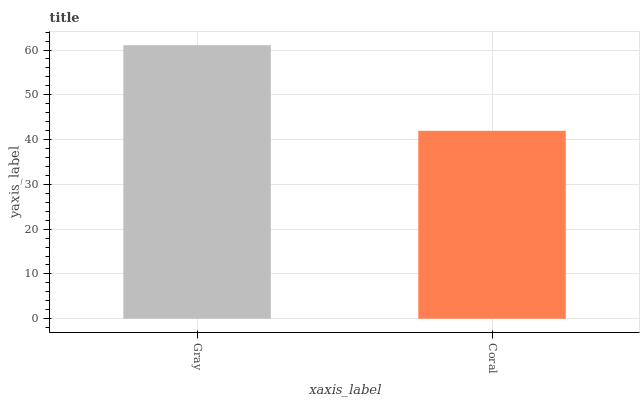Is Coral the minimum?
Answer yes or no. Yes. Is Gray the maximum?
Answer yes or no. Yes. Is Coral the maximum?
Answer yes or no. No. Is Gray greater than Coral?
Answer yes or no. Yes. Is Coral less than Gray?
Answer yes or no. Yes. Is Coral greater than Gray?
Answer yes or no. No. Is Gray less than Coral?
Answer yes or no. No. Is Gray the high median?
Answer yes or no. Yes. Is Coral the low median?
Answer yes or no. Yes. Is Coral the high median?
Answer yes or no. No. Is Gray the low median?
Answer yes or no. No. 